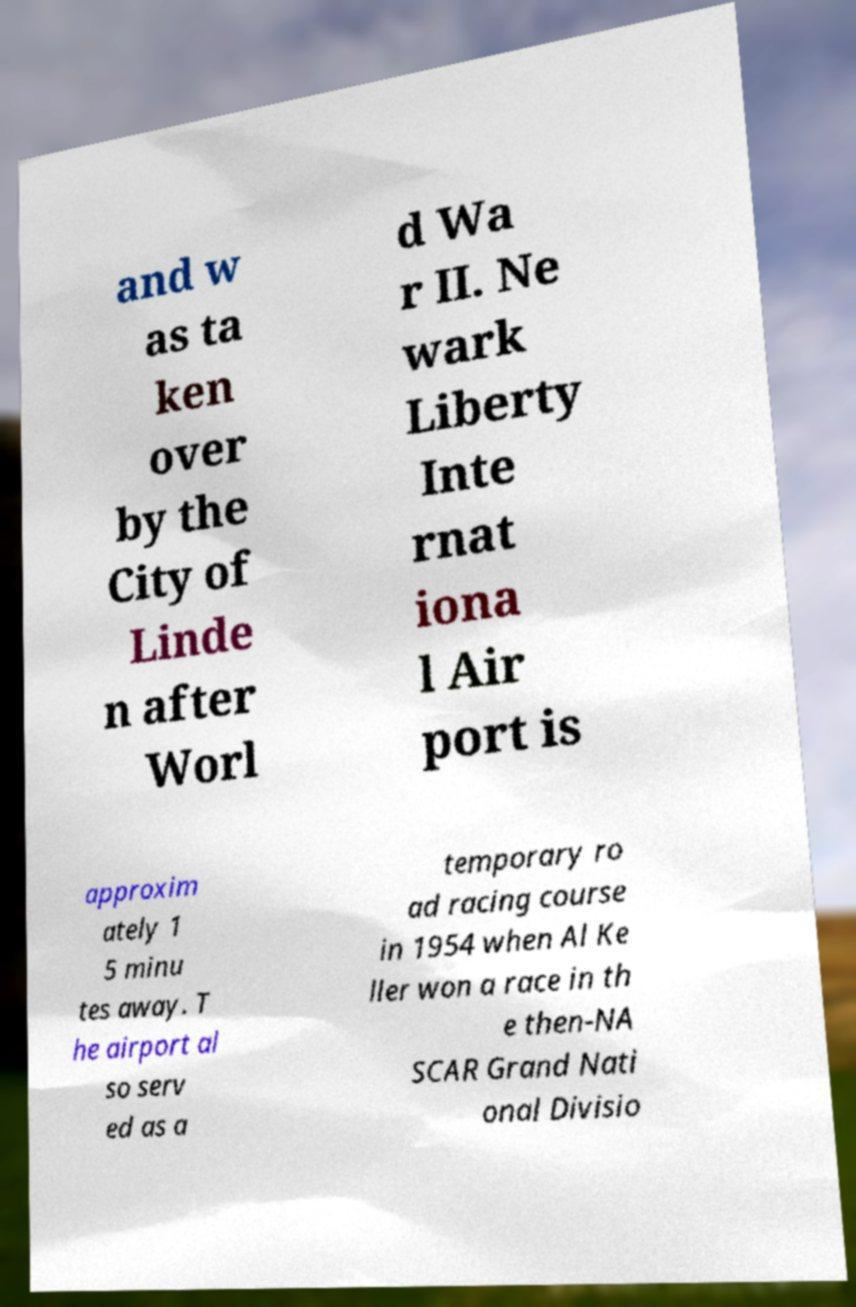I need the written content from this picture converted into text. Can you do that? and w as ta ken over by the City of Linde n after Worl d Wa r II. Ne wark Liberty Inte rnat iona l Air port is approxim ately 1 5 minu tes away. T he airport al so serv ed as a temporary ro ad racing course in 1954 when Al Ke ller won a race in th e then-NA SCAR Grand Nati onal Divisio 